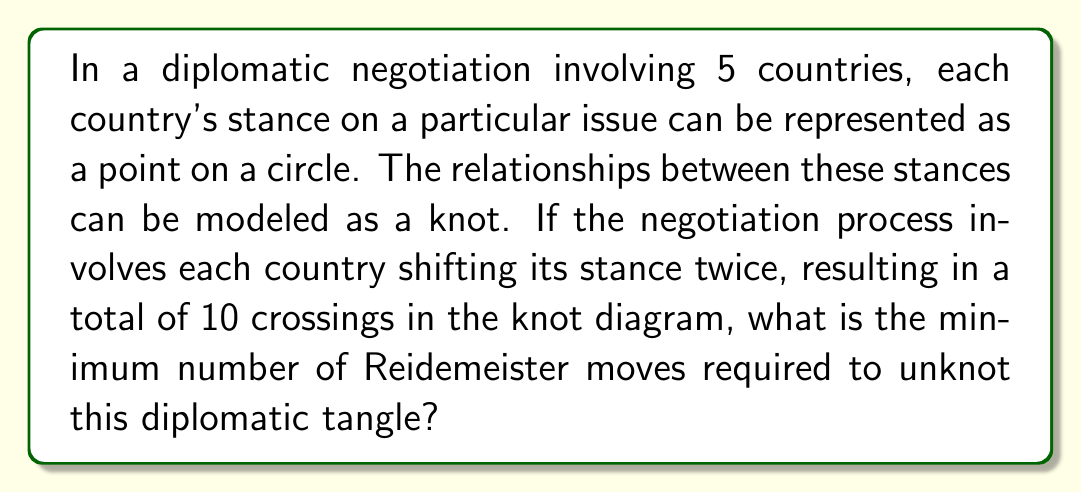What is the answer to this math problem? To solve this problem, we need to apply concepts from knot theory to diplomatic negotiations:

1) First, we recognize that the diplomatic stances form a 5-strand braid with 10 crossings.

2) In knot theory, the minimum number of Reidemeister moves required to unknot a tangle is related to the braid index and the number of crossings.

3) The braid index in this case is 5 (number of countries).

4) A general upper bound for the number of Reidemeister moves needed to unknot a knot is given by:

   $$R(K) \leq c(n^2 - n - 1)$$

   Where $R(K)$ is the number of Reidemeister moves, $c$ is the number of crossings, and $n$ is the braid index.

5) Substituting our values:

   $$R(K) \leq 10(5^2 - 5 - 1) = 10(25 - 5 - 1) = 10(19) = 190$$

6) However, this is an upper bound. For a more precise estimate, we can use the fact that each type II Reidemeister move can remove two crossings.

7) With 10 crossings, we need at least 5 type II moves to remove all crossings.

8) Additionally, we might need some type I and type III moves to rearrange the strands. A conservative estimate would be 2-3 additional moves.

9) Therefore, a reasonable minimum estimate would be 7-8 Reidemeister moves.
Answer: 8 Reidemeister moves 